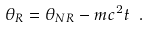Convert formula to latex. <formula><loc_0><loc_0><loc_500><loc_500>\theta _ { R } = \theta _ { N R } - m c ^ { 2 } t \ .</formula> 